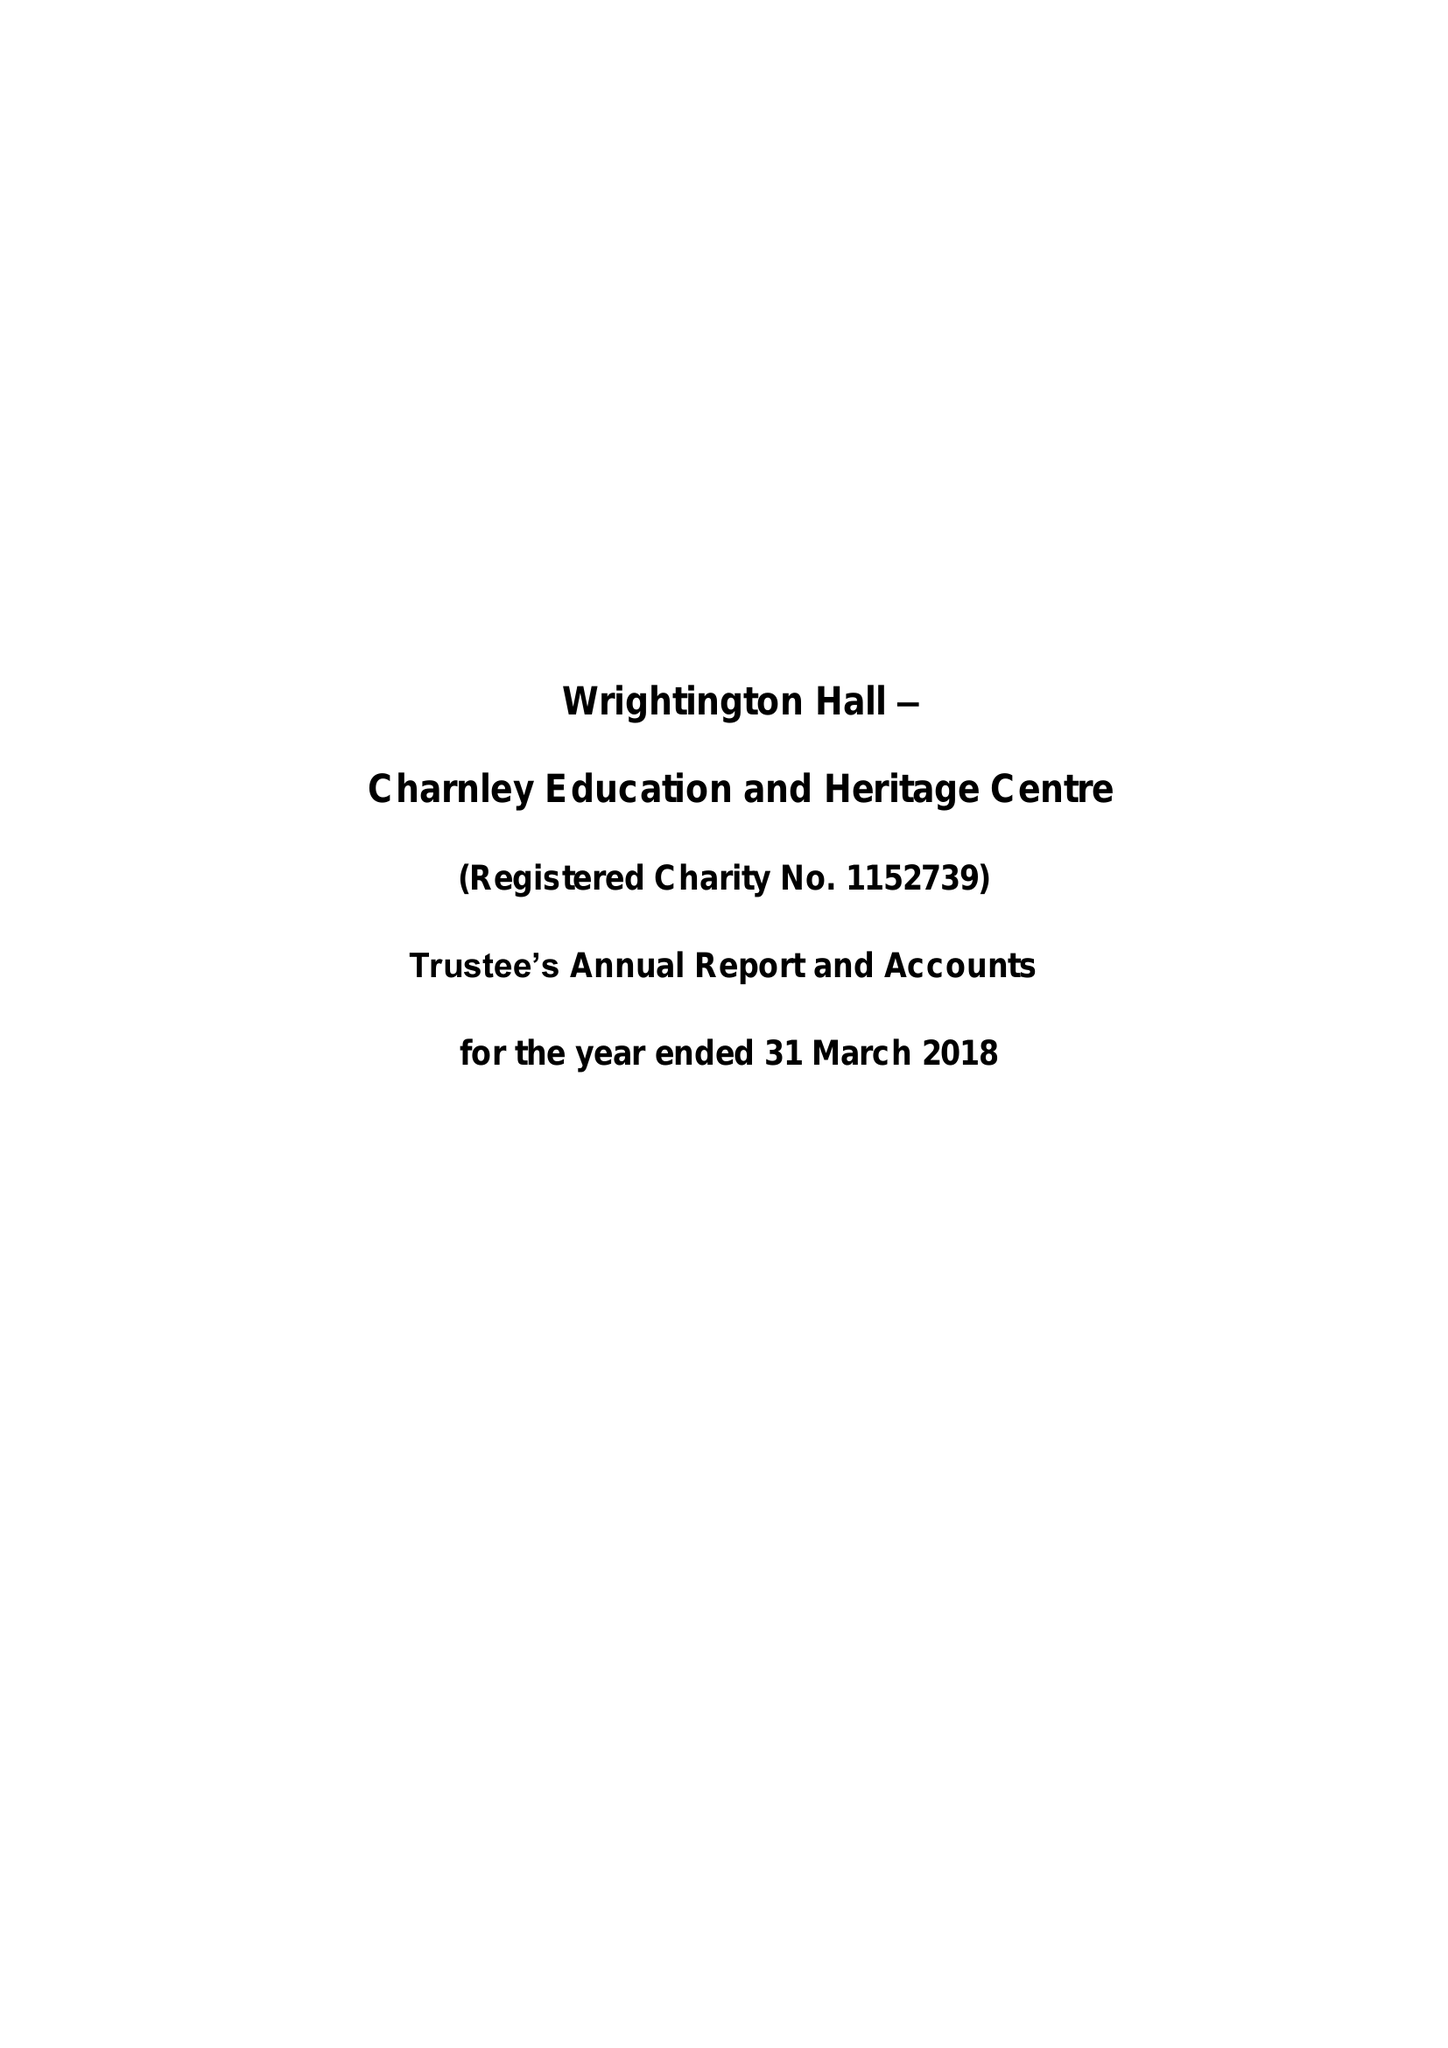What is the value for the charity_name?
Answer the question using a single word or phrase. Wrightington Hall - Charnley Education and Heritage Centre 